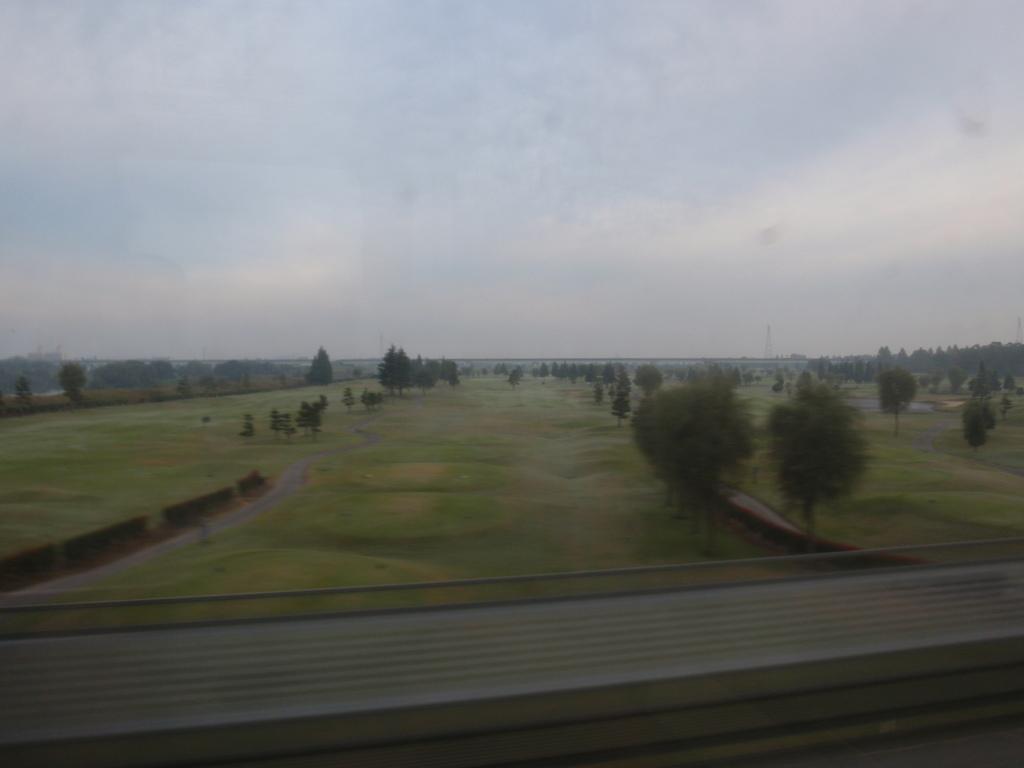Can you describe this image briefly? This is ground and there are trees. In the background we can see sky. 